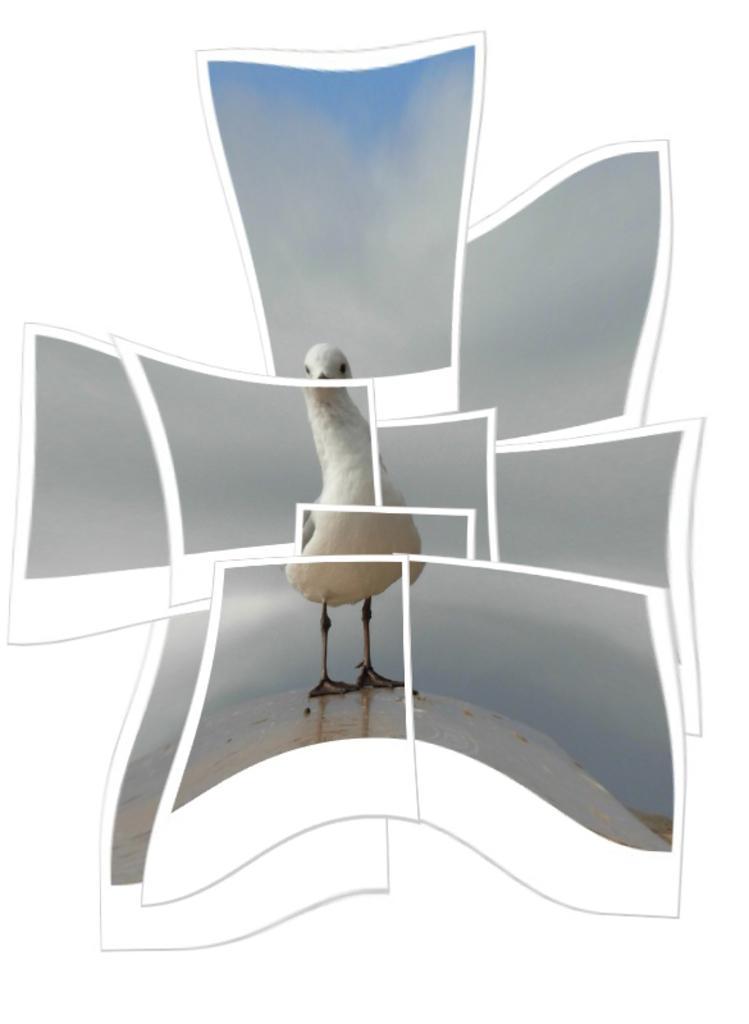In one or two sentences, can you explain what this image depicts? This image looks like it is edited. In which, we can see a bird in white color. It is standing on the ground. In the background, we can see the sky. 